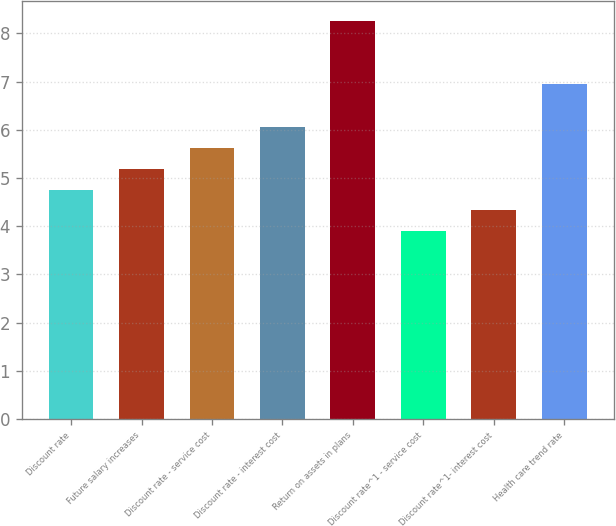<chart> <loc_0><loc_0><loc_500><loc_500><bar_chart><fcel>Discount rate<fcel>Future salary increases<fcel>Discount rate - service cost<fcel>Discount rate - interest cost<fcel>Return on assets in plans<fcel>Discount rate^1 - service cost<fcel>Discount rate^1- interest cost<fcel>Health care trend rate<nl><fcel>4.76<fcel>5.19<fcel>5.62<fcel>6.05<fcel>8.25<fcel>3.9<fcel>4.33<fcel>6.94<nl></chart> 